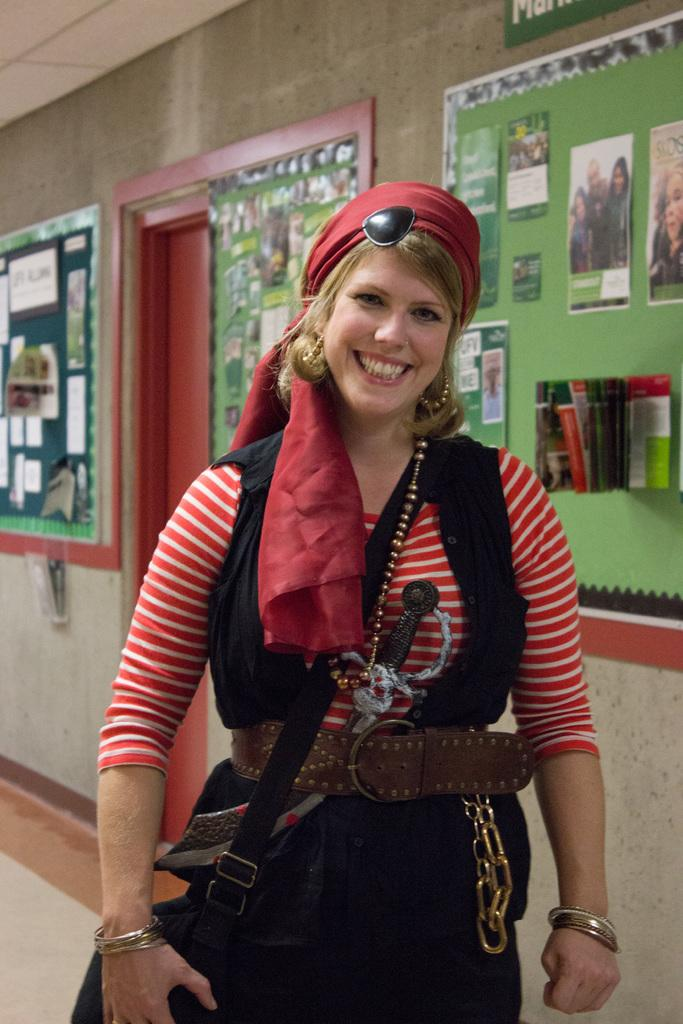What is present on the wall in the image? There are green boards on the wall in the image. What is attached to the green boards? There are posters on the green boards. Who is present in the image besides the wall? There is a woman standing in the image. What is the woman wearing? The woman is wearing a bag. How is the woman's facial expression in the image? The woman has a smile on her face. What is the woman's tendency to use her muscles in the image? There is no information about the woman's muscle usage or tendencies in the image. 